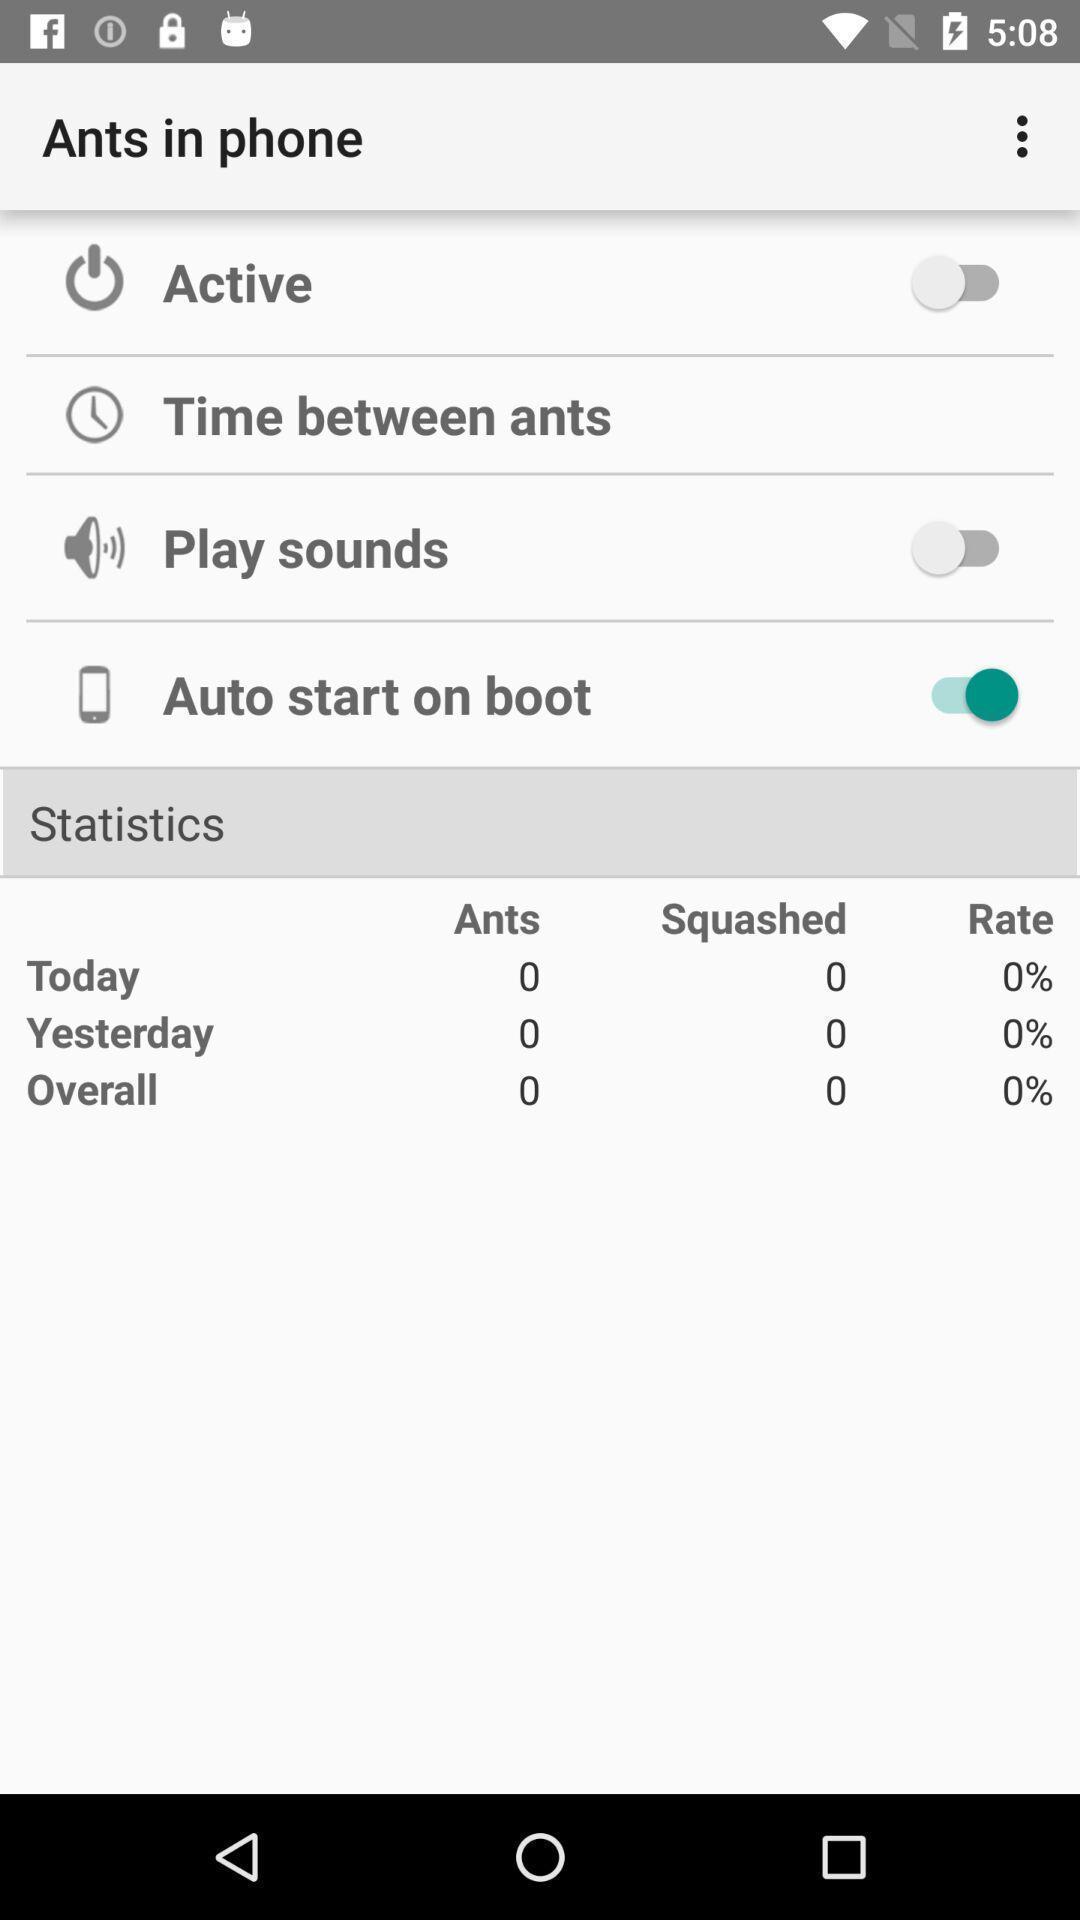Describe the visual elements of this screenshot. Screen showing list of various options. 